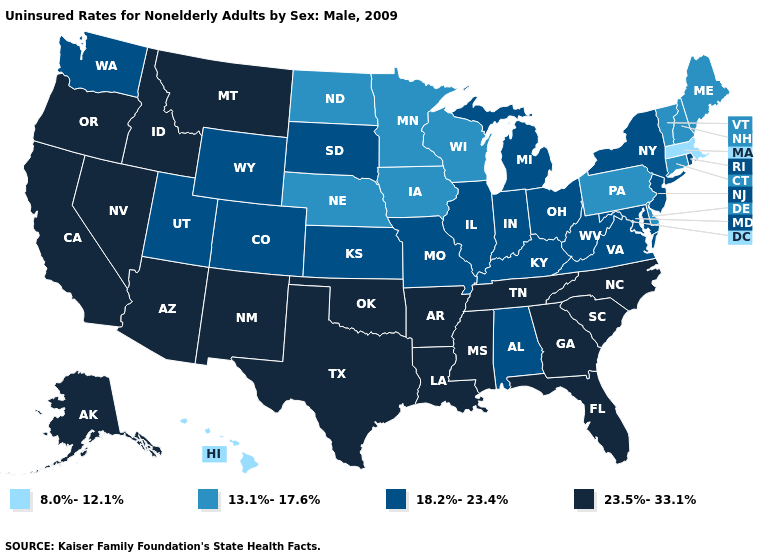Does the map have missing data?
Write a very short answer. No. Among the states that border Mississippi , which have the lowest value?
Answer briefly. Alabama. Name the states that have a value in the range 8.0%-12.1%?
Short answer required. Hawaii, Massachusetts. Name the states that have a value in the range 13.1%-17.6%?
Short answer required. Connecticut, Delaware, Iowa, Maine, Minnesota, Nebraska, New Hampshire, North Dakota, Pennsylvania, Vermont, Wisconsin. What is the lowest value in the West?
Keep it brief. 8.0%-12.1%. Name the states that have a value in the range 18.2%-23.4%?
Answer briefly. Alabama, Colorado, Illinois, Indiana, Kansas, Kentucky, Maryland, Michigan, Missouri, New Jersey, New York, Ohio, Rhode Island, South Dakota, Utah, Virginia, Washington, West Virginia, Wyoming. Name the states that have a value in the range 8.0%-12.1%?
Be succinct. Hawaii, Massachusetts. Which states have the lowest value in the South?
Give a very brief answer. Delaware. What is the value of Minnesota?
Concise answer only. 13.1%-17.6%. What is the value of New Hampshire?
Keep it brief. 13.1%-17.6%. Is the legend a continuous bar?
Short answer required. No. Name the states that have a value in the range 18.2%-23.4%?
Give a very brief answer. Alabama, Colorado, Illinois, Indiana, Kansas, Kentucky, Maryland, Michigan, Missouri, New Jersey, New York, Ohio, Rhode Island, South Dakota, Utah, Virginia, Washington, West Virginia, Wyoming. Does the map have missing data?
Quick response, please. No. Does Maryland have the same value as Arkansas?
Answer briefly. No. Among the states that border North Dakota , which have the highest value?
Concise answer only. Montana. 